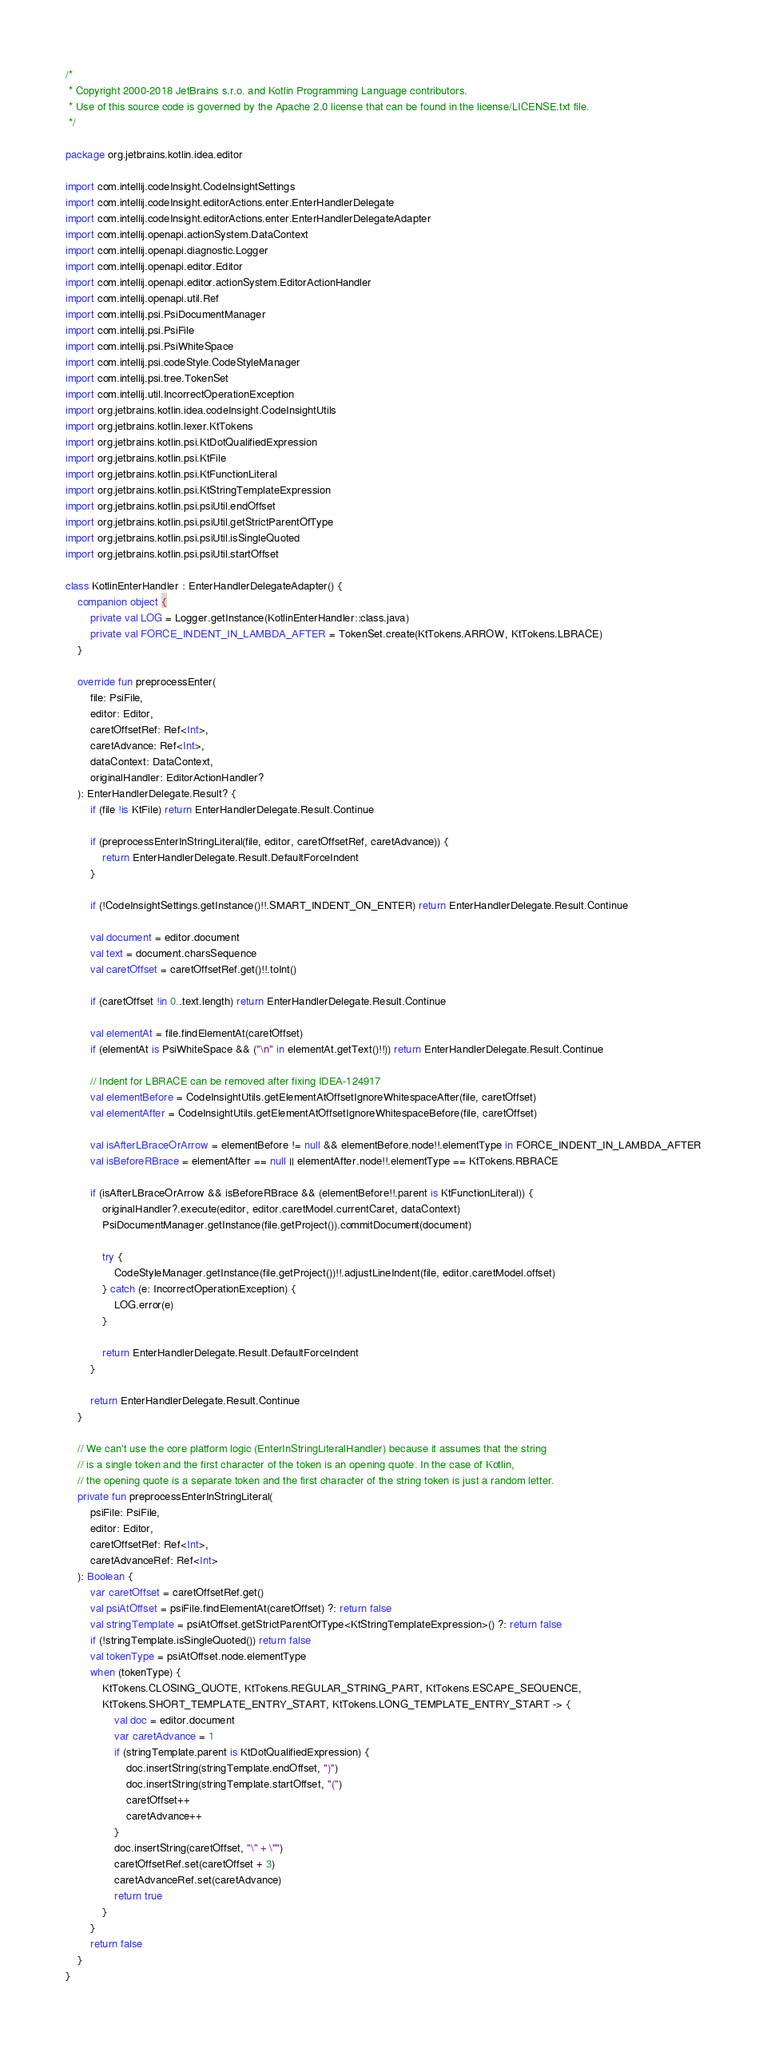Convert code to text. <code><loc_0><loc_0><loc_500><loc_500><_Kotlin_>/*
 * Copyright 2000-2018 JetBrains s.r.o. and Kotlin Programming Language contributors.
 * Use of this source code is governed by the Apache 2.0 license that can be found in the license/LICENSE.txt file.
 */

package org.jetbrains.kotlin.idea.editor

import com.intellij.codeInsight.CodeInsightSettings
import com.intellij.codeInsight.editorActions.enter.EnterHandlerDelegate
import com.intellij.codeInsight.editorActions.enter.EnterHandlerDelegateAdapter
import com.intellij.openapi.actionSystem.DataContext
import com.intellij.openapi.diagnostic.Logger
import com.intellij.openapi.editor.Editor
import com.intellij.openapi.editor.actionSystem.EditorActionHandler
import com.intellij.openapi.util.Ref
import com.intellij.psi.PsiDocumentManager
import com.intellij.psi.PsiFile
import com.intellij.psi.PsiWhiteSpace
import com.intellij.psi.codeStyle.CodeStyleManager
import com.intellij.psi.tree.TokenSet
import com.intellij.util.IncorrectOperationException
import org.jetbrains.kotlin.idea.codeInsight.CodeInsightUtils
import org.jetbrains.kotlin.lexer.KtTokens
import org.jetbrains.kotlin.psi.KtDotQualifiedExpression
import org.jetbrains.kotlin.psi.KtFile
import org.jetbrains.kotlin.psi.KtFunctionLiteral
import org.jetbrains.kotlin.psi.KtStringTemplateExpression
import org.jetbrains.kotlin.psi.psiUtil.endOffset
import org.jetbrains.kotlin.psi.psiUtil.getStrictParentOfType
import org.jetbrains.kotlin.psi.psiUtil.isSingleQuoted
import org.jetbrains.kotlin.psi.psiUtil.startOffset

class KotlinEnterHandler : EnterHandlerDelegateAdapter() {
    companion object {
        private val LOG = Logger.getInstance(KotlinEnterHandler::class.java)
        private val FORCE_INDENT_IN_LAMBDA_AFTER = TokenSet.create(KtTokens.ARROW, KtTokens.LBRACE)
    }

    override fun preprocessEnter(
        file: PsiFile,
        editor: Editor,
        caretOffsetRef: Ref<Int>,
        caretAdvance: Ref<Int>,
        dataContext: DataContext,
        originalHandler: EditorActionHandler?
    ): EnterHandlerDelegate.Result? {
        if (file !is KtFile) return EnterHandlerDelegate.Result.Continue

        if (preprocessEnterInStringLiteral(file, editor, caretOffsetRef, caretAdvance)) {
            return EnterHandlerDelegate.Result.DefaultForceIndent
        }

        if (!CodeInsightSettings.getInstance()!!.SMART_INDENT_ON_ENTER) return EnterHandlerDelegate.Result.Continue

        val document = editor.document
        val text = document.charsSequence
        val caretOffset = caretOffsetRef.get()!!.toInt()

        if (caretOffset !in 0..text.length) return EnterHandlerDelegate.Result.Continue

        val elementAt = file.findElementAt(caretOffset)
        if (elementAt is PsiWhiteSpace && ("\n" in elementAt.getText()!!)) return EnterHandlerDelegate.Result.Continue

        // Indent for LBRACE can be removed after fixing IDEA-124917
        val elementBefore = CodeInsightUtils.getElementAtOffsetIgnoreWhitespaceAfter(file, caretOffset)
        val elementAfter = CodeInsightUtils.getElementAtOffsetIgnoreWhitespaceBefore(file, caretOffset)

        val isAfterLBraceOrArrow = elementBefore != null && elementBefore.node!!.elementType in FORCE_INDENT_IN_LAMBDA_AFTER
        val isBeforeRBrace = elementAfter == null || elementAfter.node!!.elementType == KtTokens.RBRACE

        if (isAfterLBraceOrArrow && isBeforeRBrace && (elementBefore!!.parent is KtFunctionLiteral)) {
            originalHandler?.execute(editor, editor.caretModel.currentCaret, dataContext)
            PsiDocumentManager.getInstance(file.getProject()).commitDocument(document)

            try {
                CodeStyleManager.getInstance(file.getProject())!!.adjustLineIndent(file, editor.caretModel.offset)
            } catch (e: IncorrectOperationException) {
                LOG.error(e)
            }

            return EnterHandlerDelegate.Result.DefaultForceIndent
        }

        return EnterHandlerDelegate.Result.Continue
    }

    // We can't use the core platform logic (EnterInStringLiteralHandler) because it assumes that the string
    // is a single token and the first character of the token is an opening quote. In the case of Kotlin,
    // the opening quote is a separate token and the first character of the string token is just a random letter.
    private fun preprocessEnterInStringLiteral(
        psiFile: PsiFile,
        editor: Editor,
        caretOffsetRef: Ref<Int>,
        caretAdvanceRef: Ref<Int>
    ): Boolean {
        var caretOffset = caretOffsetRef.get()
        val psiAtOffset = psiFile.findElementAt(caretOffset) ?: return false
        val stringTemplate = psiAtOffset.getStrictParentOfType<KtStringTemplateExpression>() ?: return false
        if (!stringTemplate.isSingleQuoted()) return false
        val tokenType = psiAtOffset.node.elementType
        when (tokenType) {
            KtTokens.CLOSING_QUOTE, KtTokens.REGULAR_STRING_PART, KtTokens.ESCAPE_SEQUENCE,
            KtTokens.SHORT_TEMPLATE_ENTRY_START, KtTokens.LONG_TEMPLATE_ENTRY_START -> {
                val doc = editor.document
                var caretAdvance = 1
                if (stringTemplate.parent is KtDotQualifiedExpression) {
                    doc.insertString(stringTemplate.endOffset, ")")
                    doc.insertString(stringTemplate.startOffset, "(")
                    caretOffset++
                    caretAdvance++
                }
                doc.insertString(caretOffset, "\" + \"")
                caretOffsetRef.set(caretOffset + 3)
                caretAdvanceRef.set(caretAdvance)
                return true
            }
        }
        return false
    }
}
</code> 